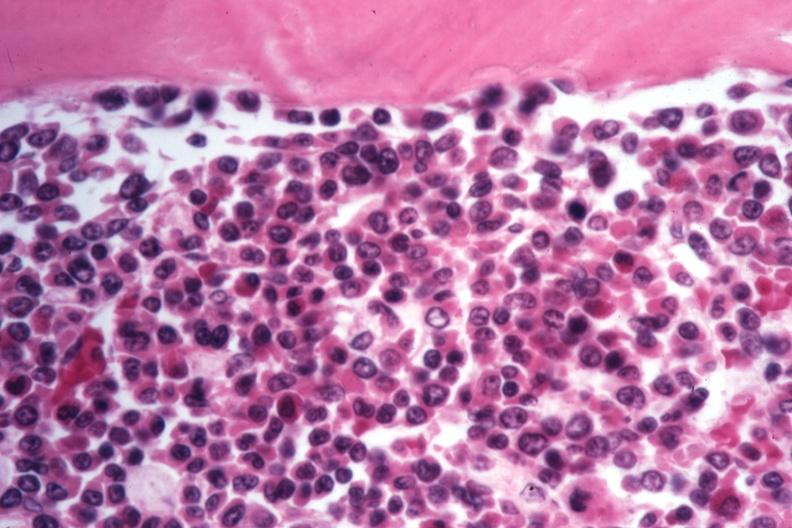what is present?
Answer the question using a single word or phrase. Chronic myelogenous leukemia 